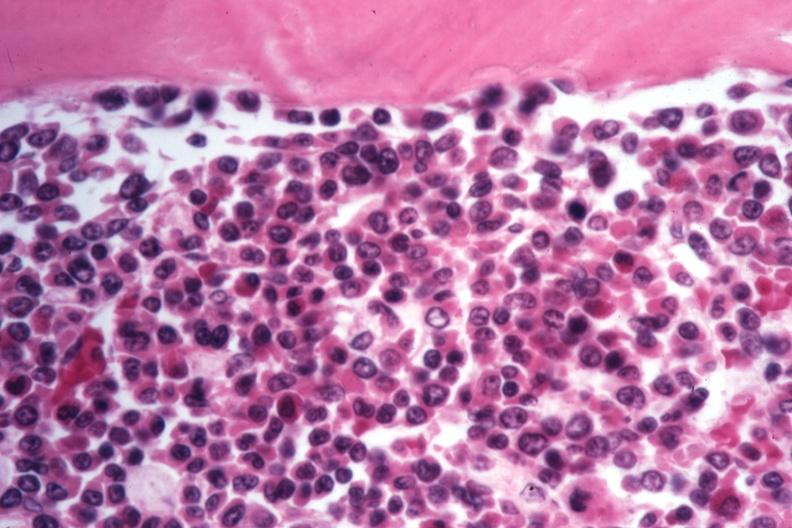what is present?
Answer the question using a single word or phrase. Chronic myelogenous leukemia 